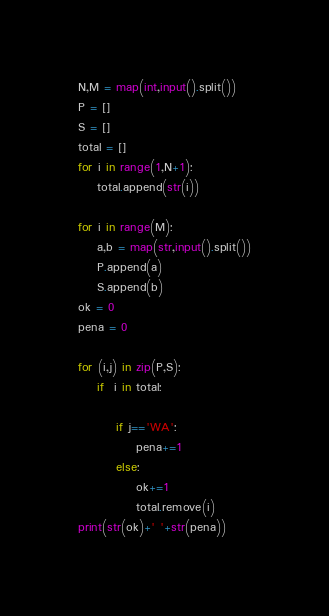Convert code to text. <code><loc_0><loc_0><loc_500><loc_500><_Python_>N,M = map(int,input().split())
P = []
S = []
total = []
for i in range(1,N+1):
    total.append(str(i))

for i in range(M):
    a,b = map(str,input().split())
    P.append(a)
    S.append(b)
ok = 0
pena = 0

for (i,j) in zip(P,S):
    if  i in total:
        
        if j=='WA':
            pena+=1
        else:
            ok+=1
            total.remove(i)
print(str(ok)+' '+str(pena))


</code> 